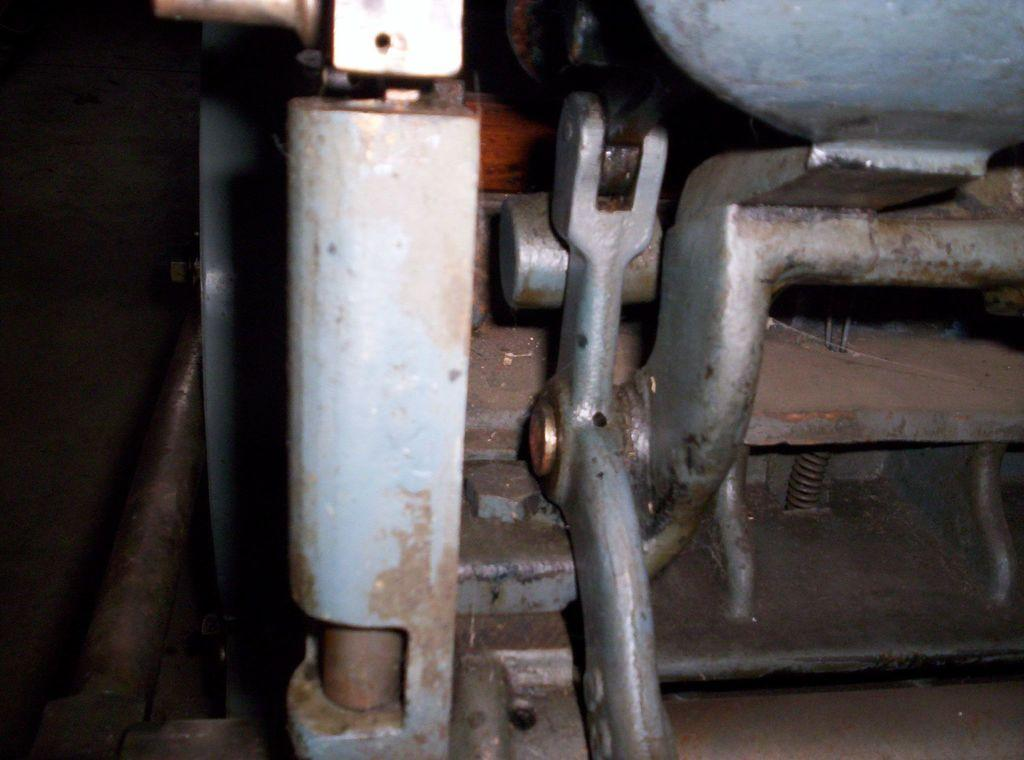What is the main subject of the image? There is a machine in the image. What type of objects can be seen in the image? There are metal objects in the image. What type of rock can be seen in the image? There is no rock present in the image; it features a machine and metal objects. What sense is being stimulated by the objects in the image? The image does not depict any objects that stimulate a specific sense. 